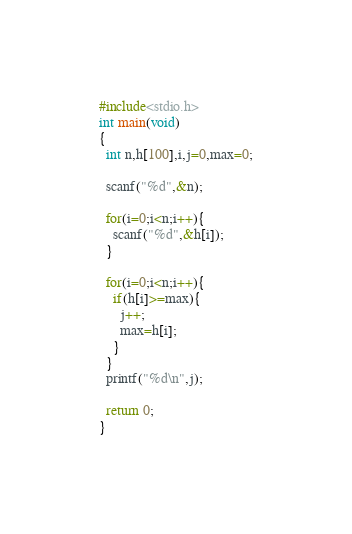<code> <loc_0><loc_0><loc_500><loc_500><_C_>#include<stdio.h>
int main(void)
{
  int n,h[100],i,j=0,max=0;

  scanf("%d",&n);

  for(i=0;i<n;i++){
    scanf("%d",&h[i]);
  }

  for(i=0;i<n;i++){
    if(h[i]>=max){
      j++;
      max=h[i];
    }
  }
  printf("%d\n",j);

  return 0;
}
</code> 